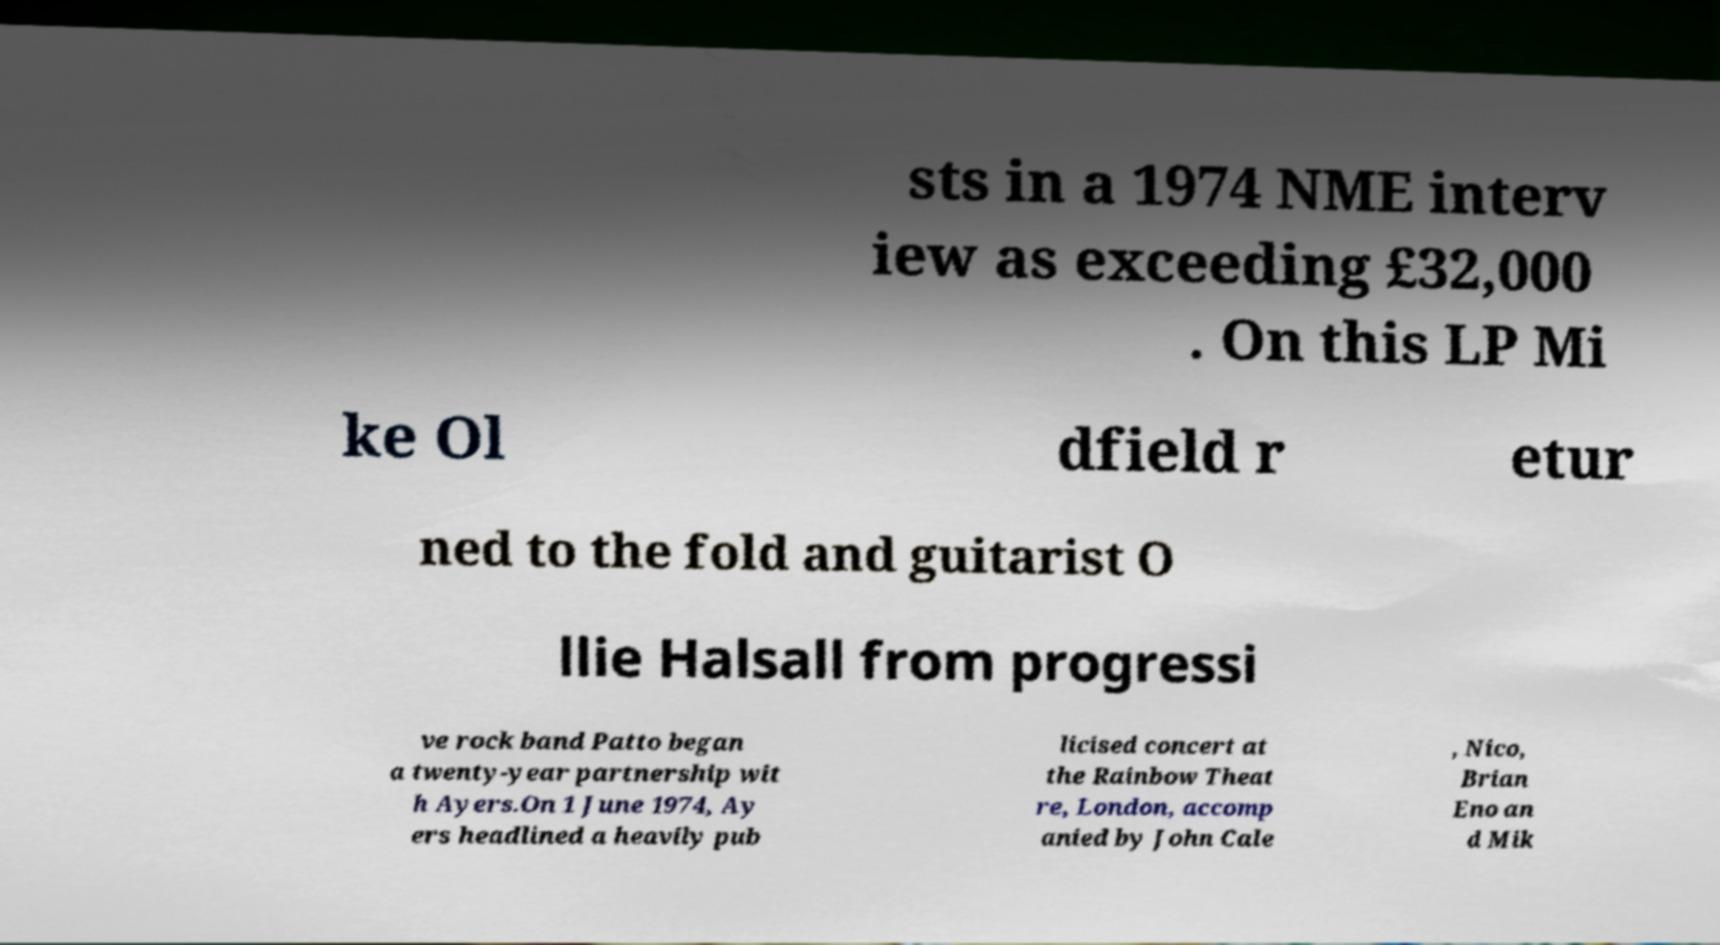Could you extract and type out the text from this image? sts in a 1974 NME interv iew as exceeding £32,000 . On this LP Mi ke Ol dfield r etur ned to the fold and guitarist O llie Halsall from progressi ve rock band Patto began a twenty-year partnership wit h Ayers.On 1 June 1974, Ay ers headlined a heavily pub licised concert at the Rainbow Theat re, London, accomp anied by John Cale , Nico, Brian Eno an d Mik 